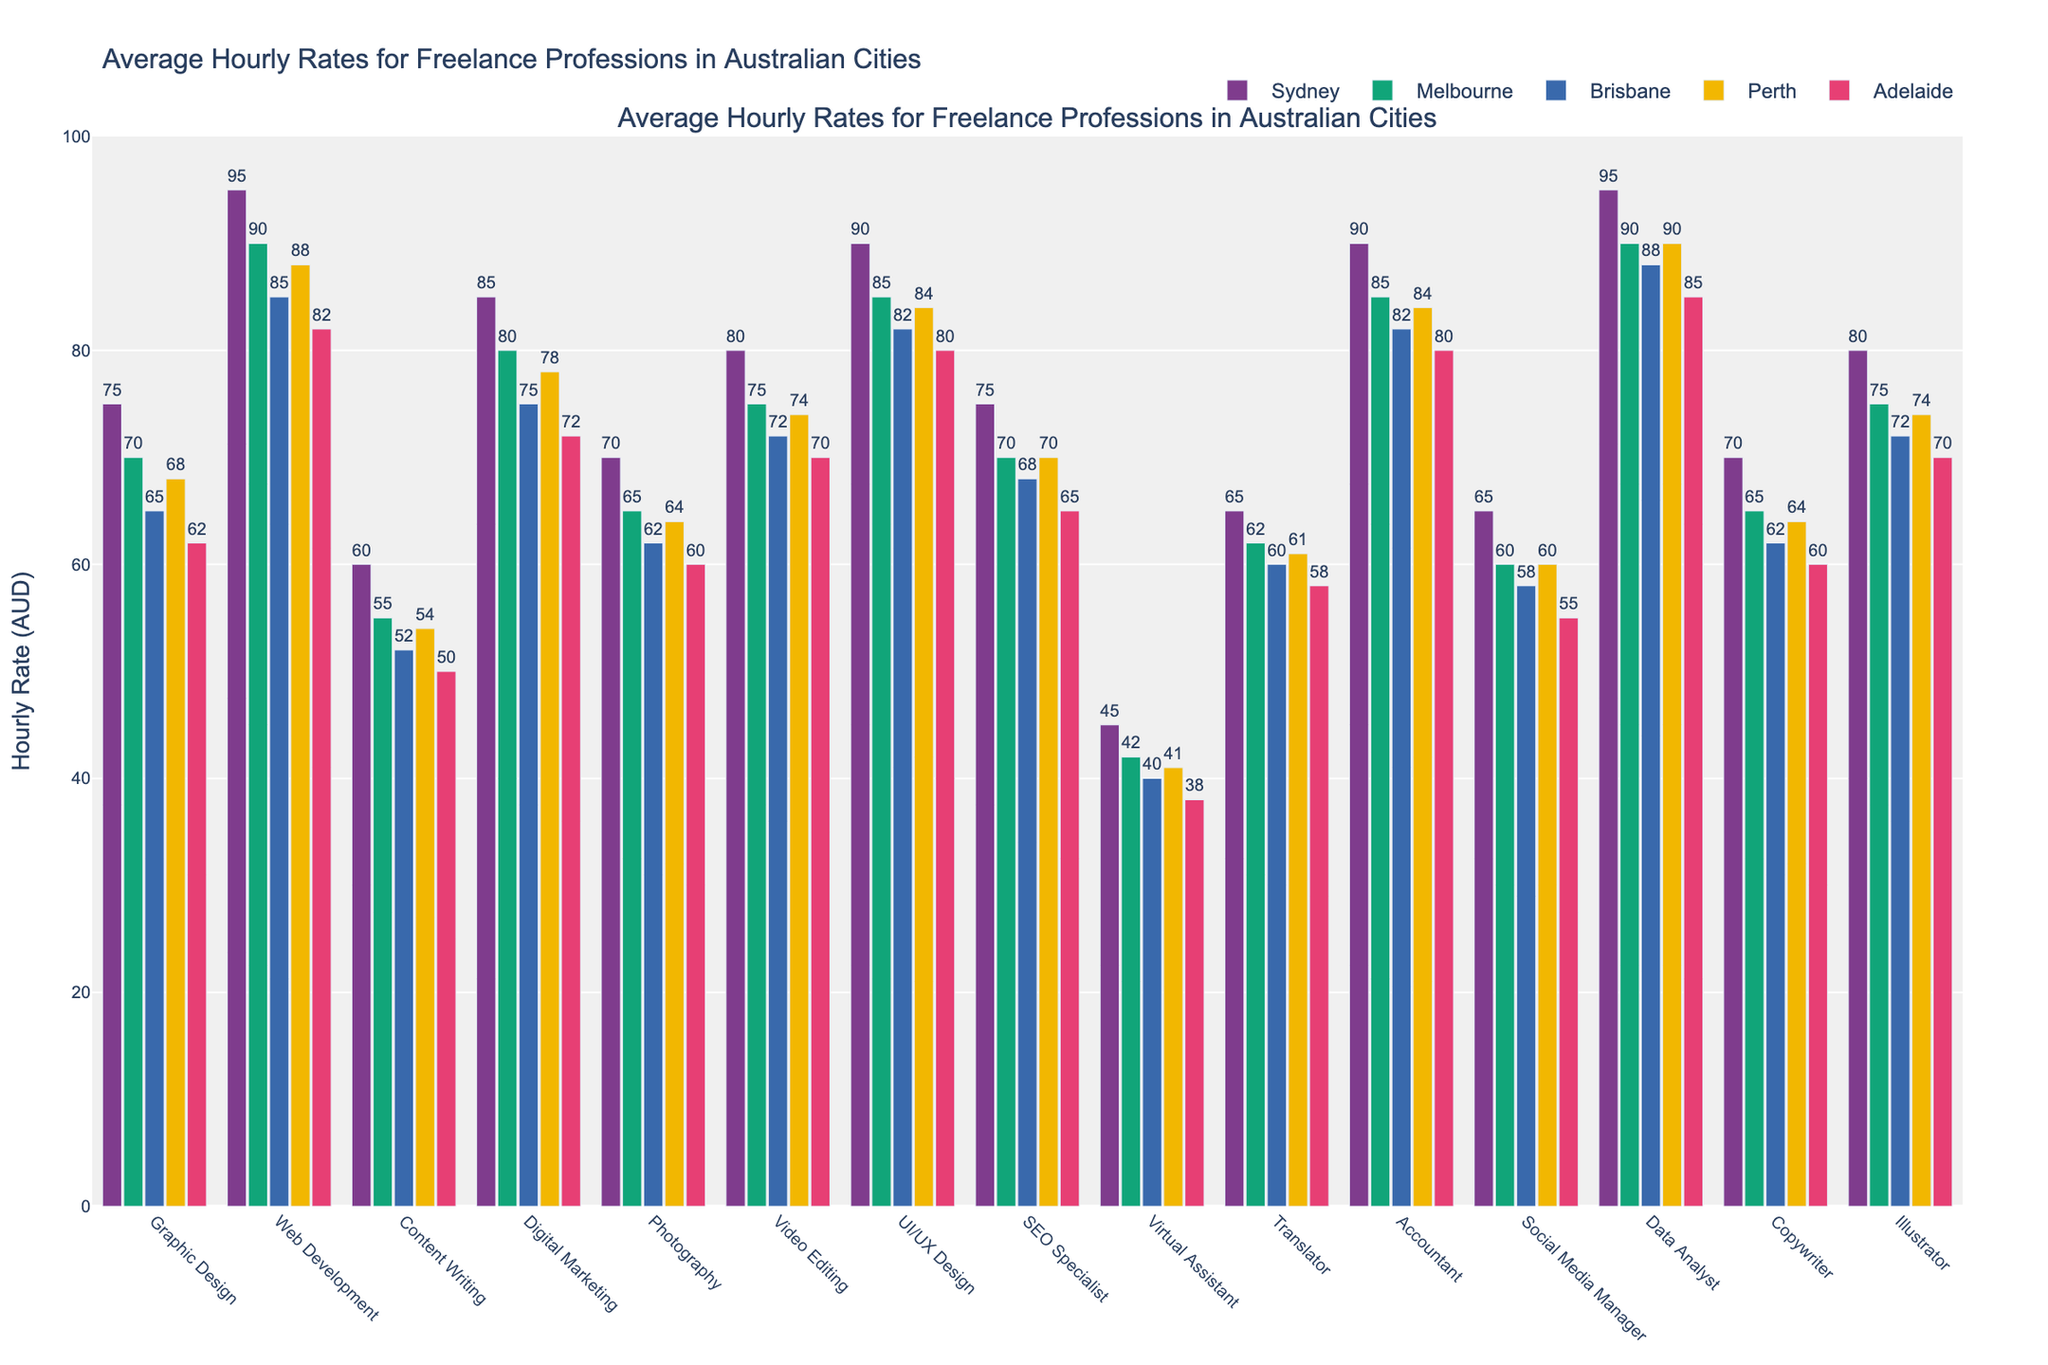Which city has the highest average hourly rate for Web Development? The highest bar for Web Development is in Sydney, indicating Sydney has the highest average hourly rate.
Answer: Sydney What is the median hourly rate for Digital Marketing across all cities? Sort hourly rates for Digital Marketing from lowest to highest: 72, 75, 78, 80, 85. The median value is the middle one, 78.
Answer: 78 Which profession has the lowest hourly rate in Adelaide? By visually identifying the shortest bar in Adelaide, we see that Virtual Assistant has the lowest hourly rate.
Answer: Virtual Assistant What is the difference in hourly rates for Data Analyst between Sydney and Adelaide? The hourly rate for Data Analyst in Sydney is 95, and in Adelaide, it is 85. The difference is 95 - 85.
Answer: 10 Among these professions, which one has a larger hourly rate in Melbourne compared to Brisbane? Check bars in Melbourne and Brisbane for all professions and compare their heights. Web Development, Digital Marketing, Video Editing, UI/UX Design, Data Analyst, Accountant, and Illustrator have higher rates in Melbourne than Brisbane.
Answer: Web Development, Digital Marketing, Video Editing, UI/UX Design, Data Analyst, Accountant, Illustrator What is the average hourly rate for Content Writing in Sydney, Melbourne, and Brisbane? Add rates for Content Writing in Sydney (60), Melbourne (55), and Brisbane (52), then divide by 3. (60 + 55 + 52) / 3 = 55.67
Answer: 55.67 Which profession shows the smallest range in hourly rates among all cities? Calculate the range (max - min) for each profession across all cities. Translator has rates of 65, 62, 60, 61, 58, so the range is 65 - 58 = 7. Illustrator's rates are 80, 75, 72, 74, 70, range being 80 - 70 = 10. Check all professions similarly to find the smallest range.
Answer: Translator How does the hourly rate for Graphic Design in Brisbane compare to Perth? Looking at Graphic Design bars in Brisbane and Perth, Brisbane has 65 and Perth has 68, so Brisbane is lower.
Answer: Brisbane is lower Which profession has an equal hourly rate in both Sydney and Melbourne? Compare bars for all professions in Sydney and Melbourne, and see that both UI/UX Design and Accountant share equal hourly rates in both cities (90 for UI/UX Design and 85 for Accountant).
Answer: UI/UX Design, Accountant 